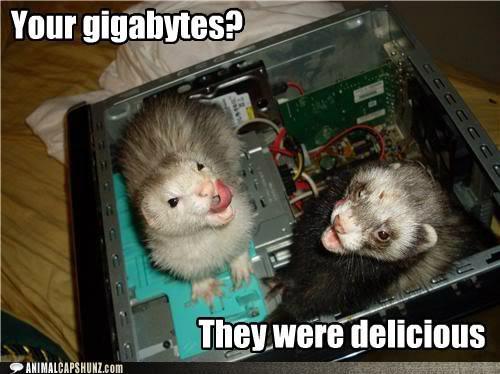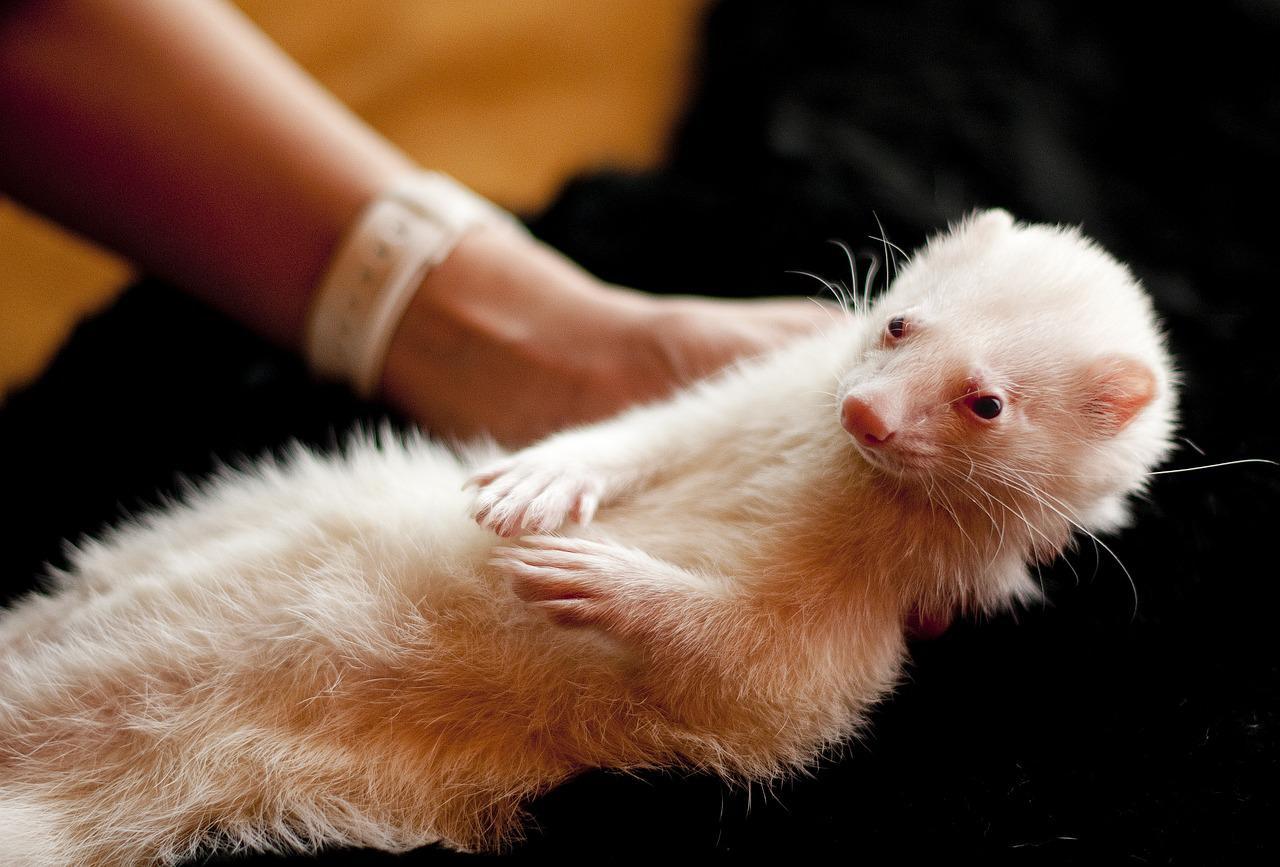The first image is the image on the left, the second image is the image on the right. Evaluate the accuracy of this statement regarding the images: "The left image contains two ferrets.". Is it true? Answer yes or no. Yes. The first image is the image on the left, the second image is the image on the right. Considering the images on both sides, is "At least one ferret has its front paws draped over an edge, and multiple ferrets are peering forward." valid? Answer yes or no. No. 